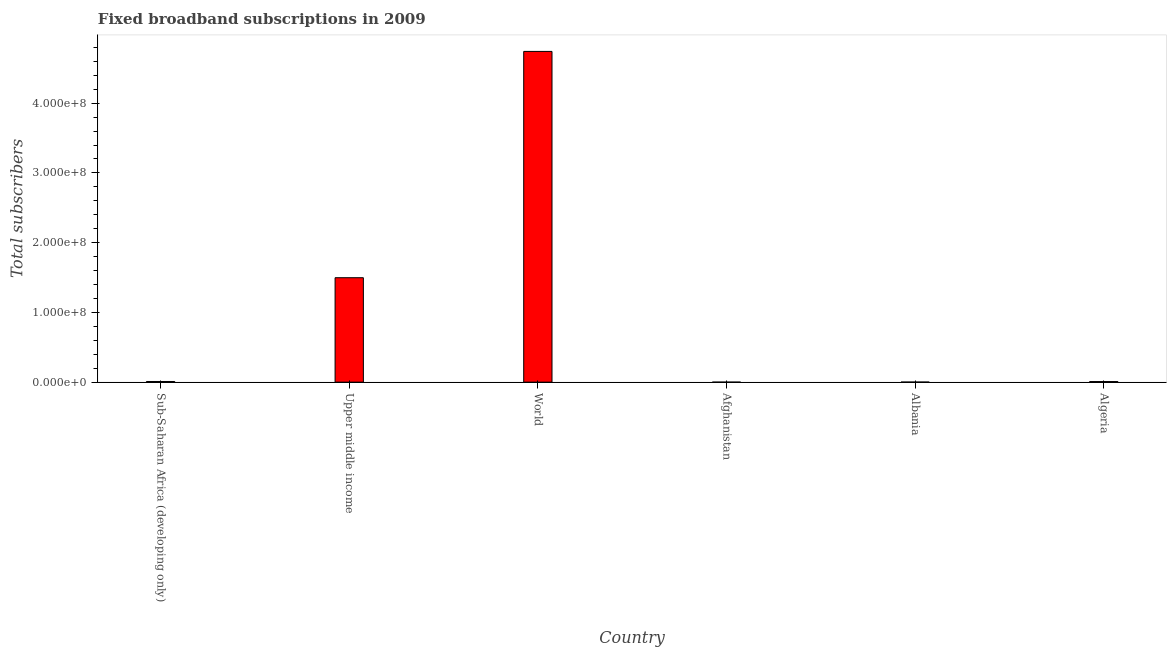What is the title of the graph?
Provide a succinct answer. Fixed broadband subscriptions in 2009. What is the label or title of the X-axis?
Your answer should be very brief. Country. What is the label or title of the Y-axis?
Provide a short and direct response. Total subscribers. What is the total number of fixed broadband subscriptions in World?
Provide a short and direct response. 4.74e+08. Across all countries, what is the maximum total number of fixed broadband subscriptions?
Offer a very short reply. 4.74e+08. Across all countries, what is the minimum total number of fixed broadband subscriptions?
Ensure brevity in your answer.  1000. In which country was the total number of fixed broadband subscriptions minimum?
Give a very brief answer. Afghanistan. What is the sum of the total number of fixed broadband subscriptions?
Your answer should be compact. 6.26e+08. What is the difference between the total number of fixed broadband subscriptions in Afghanistan and World?
Offer a terse response. -4.74e+08. What is the average total number of fixed broadband subscriptions per country?
Provide a short and direct response. 1.04e+08. What is the median total number of fixed broadband subscriptions?
Ensure brevity in your answer.  8.82e+05. In how many countries, is the total number of fixed broadband subscriptions greater than 80000000 ?
Your answer should be very brief. 2. What is the ratio of the total number of fixed broadband subscriptions in Albania to that in Algeria?
Provide a short and direct response. 0.11. Is the difference between the total number of fixed broadband subscriptions in Afghanistan and Sub-Saharan Africa (developing only) greater than the difference between any two countries?
Give a very brief answer. No. What is the difference between the highest and the second highest total number of fixed broadband subscriptions?
Provide a short and direct response. 3.25e+08. Is the sum of the total number of fixed broadband subscriptions in Algeria and Upper middle income greater than the maximum total number of fixed broadband subscriptions across all countries?
Offer a terse response. No. What is the difference between the highest and the lowest total number of fixed broadband subscriptions?
Make the answer very short. 4.74e+08. In how many countries, is the total number of fixed broadband subscriptions greater than the average total number of fixed broadband subscriptions taken over all countries?
Offer a terse response. 2. What is the Total subscribers of Sub-Saharan Africa (developing only)?
Provide a short and direct response. 9.47e+05. What is the Total subscribers of Upper middle income?
Offer a very short reply. 1.50e+08. What is the Total subscribers of World?
Your answer should be very brief. 4.74e+08. What is the Total subscribers in Albania?
Keep it short and to the point. 9.20e+04. What is the Total subscribers of Algeria?
Your answer should be very brief. 8.18e+05. What is the difference between the Total subscribers in Sub-Saharan Africa (developing only) and Upper middle income?
Provide a succinct answer. -1.49e+08. What is the difference between the Total subscribers in Sub-Saharan Africa (developing only) and World?
Give a very brief answer. -4.73e+08. What is the difference between the Total subscribers in Sub-Saharan Africa (developing only) and Afghanistan?
Offer a very short reply. 9.46e+05. What is the difference between the Total subscribers in Sub-Saharan Africa (developing only) and Albania?
Your answer should be compact. 8.55e+05. What is the difference between the Total subscribers in Sub-Saharan Africa (developing only) and Algeria?
Give a very brief answer. 1.29e+05. What is the difference between the Total subscribers in Upper middle income and World?
Provide a succinct answer. -3.25e+08. What is the difference between the Total subscribers in Upper middle income and Afghanistan?
Keep it short and to the point. 1.50e+08. What is the difference between the Total subscribers in Upper middle income and Albania?
Offer a terse response. 1.50e+08. What is the difference between the Total subscribers in Upper middle income and Algeria?
Provide a short and direct response. 1.49e+08. What is the difference between the Total subscribers in World and Afghanistan?
Make the answer very short. 4.74e+08. What is the difference between the Total subscribers in World and Albania?
Offer a very short reply. 4.74e+08. What is the difference between the Total subscribers in World and Algeria?
Offer a terse response. 4.73e+08. What is the difference between the Total subscribers in Afghanistan and Albania?
Provide a succinct answer. -9.10e+04. What is the difference between the Total subscribers in Afghanistan and Algeria?
Provide a short and direct response. -8.17e+05. What is the difference between the Total subscribers in Albania and Algeria?
Your answer should be compact. -7.26e+05. What is the ratio of the Total subscribers in Sub-Saharan Africa (developing only) to that in Upper middle income?
Make the answer very short. 0.01. What is the ratio of the Total subscribers in Sub-Saharan Africa (developing only) to that in World?
Your response must be concise. 0. What is the ratio of the Total subscribers in Sub-Saharan Africa (developing only) to that in Afghanistan?
Keep it short and to the point. 946.51. What is the ratio of the Total subscribers in Sub-Saharan Africa (developing only) to that in Albania?
Ensure brevity in your answer.  10.29. What is the ratio of the Total subscribers in Sub-Saharan Africa (developing only) to that in Algeria?
Provide a succinct answer. 1.16. What is the ratio of the Total subscribers in Upper middle income to that in World?
Provide a succinct answer. 0.32. What is the ratio of the Total subscribers in Upper middle income to that in Afghanistan?
Offer a very short reply. 1.50e+05. What is the ratio of the Total subscribers in Upper middle income to that in Albania?
Provide a short and direct response. 1627.69. What is the ratio of the Total subscribers in Upper middle income to that in Algeria?
Ensure brevity in your answer.  183.06. What is the ratio of the Total subscribers in World to that in Afghanistan?
Your answer should be very brief. 4.74e+05. What is the ratio of the Total subscribers in World to that in Albania?
Make the answer very short. 5154.99. What is the ratio of the Total subscribers in World to that in Algeria?
Ensure brevity in your answer.  579.78. What is the ratio of the Total subscribers in Afghanistan to that in Albania?
Offer a terse response. 0.01. What is the ratio of the Total subscribers in Albania to that in Algeria?
Offer a very short reply. 0.11. 